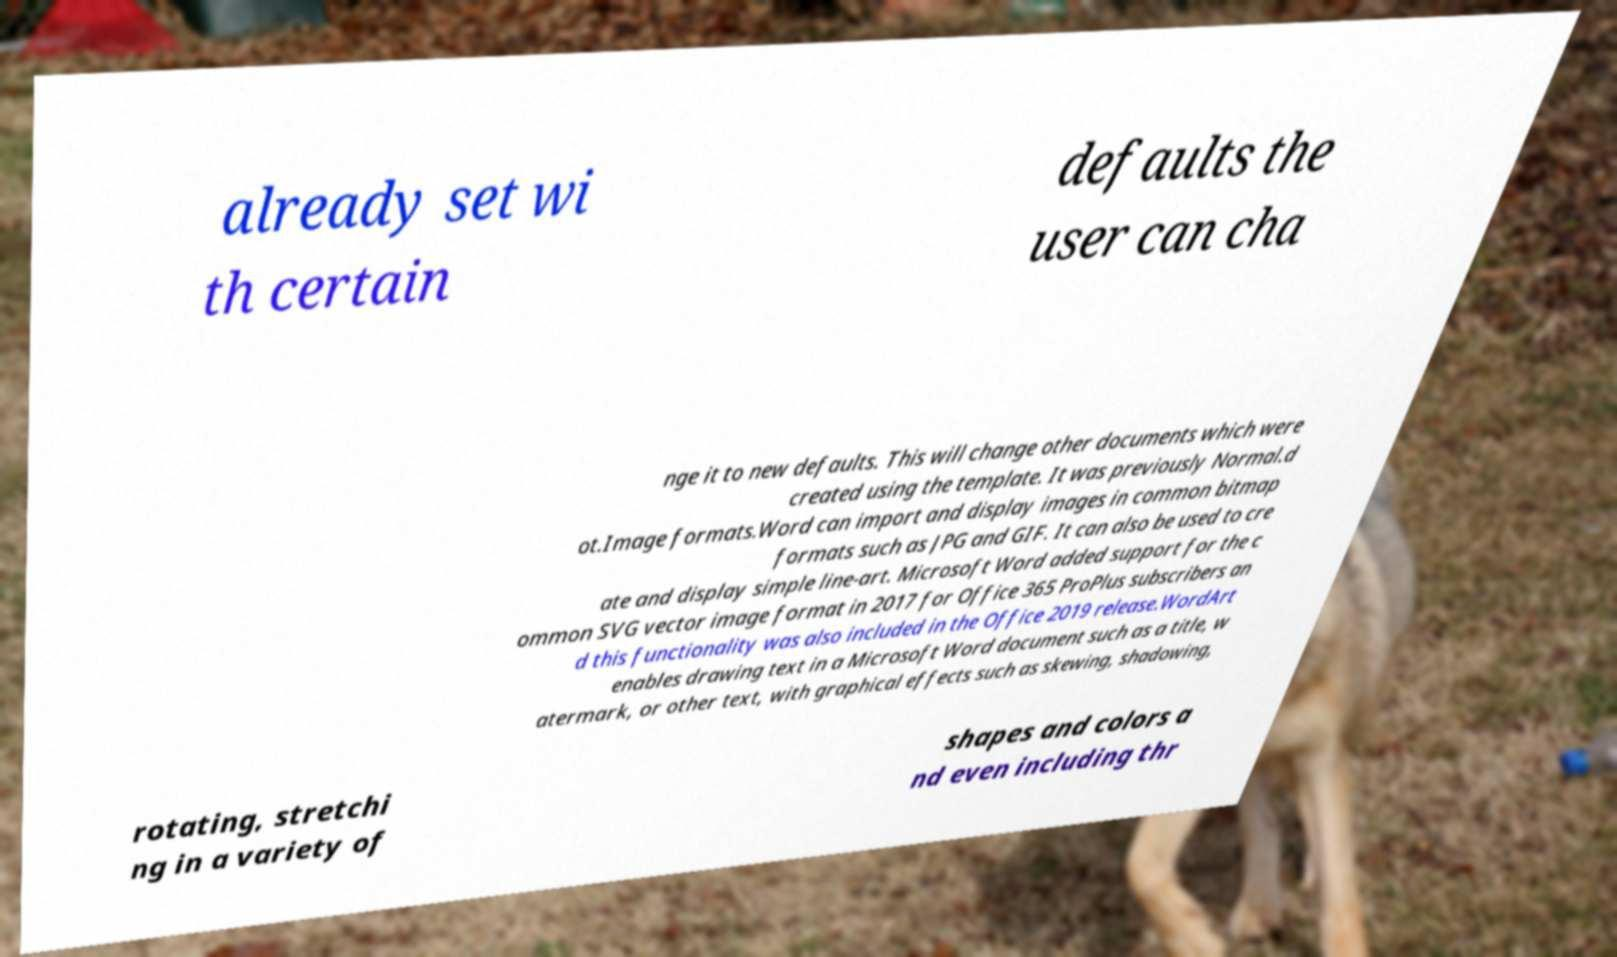I need the written content from this picture converted into text. Can you do that? already set wi th certain defaults the user can cha nge it to new defaults. This will change other documents which were created using the template. It was previously Normal.d ot.Image formats.Word can import and display images in common bitmap formats such as JPG and GIF. It can also be used to cre ate and display simple line-art. Microsoft Word added support for the c ommon SVG vector image format in 2017 for Office 365 ProPlus subscribers an d this functionality was also included in the Office 2019 release.WordArt enables drawing text in a Microsoft Word document such as a title, w atermark, or other text, with graphical effects such as skewing, shadowing, rotating, stretchi ng in a variety of shapes and colors a nd even including thr 